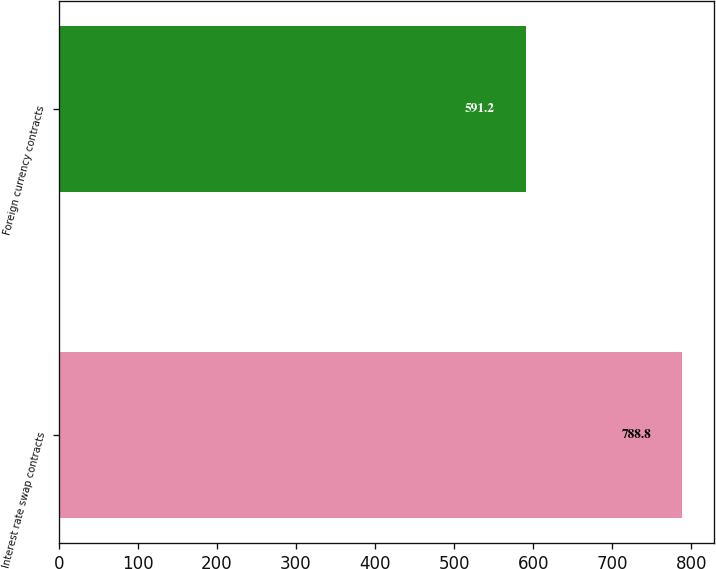Convert chart to OTSL. <chart><loc_0><loc_0><loc_500><loc_500><bar_chart><fcel>Interest rate swap contracts<fcel>Foreign currency contracts<nl><fcel>788.8<fcel>591.2<nl></chart> 